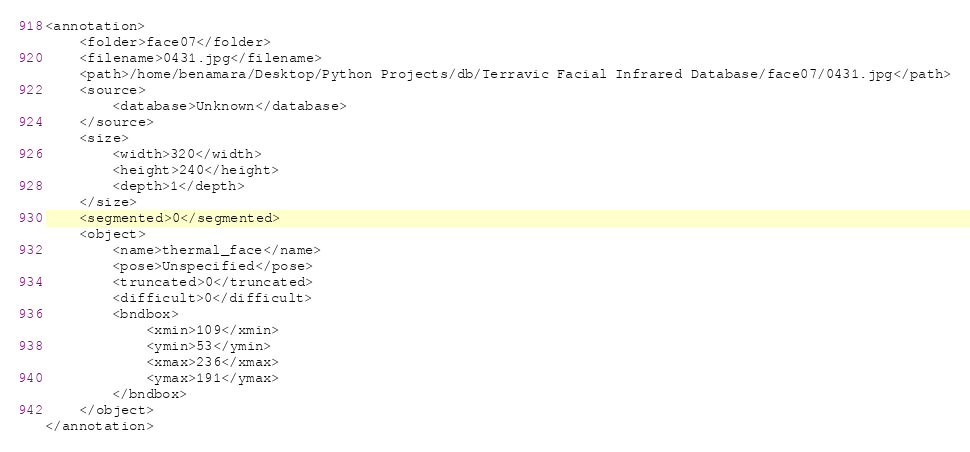Convert code to text. <code><loc_0><loc_0><loc_500><loc_500><_XML_><annotation>
	<folder>face07</folder>
	<filename>0431.jpg</filename>
	<path>/home/benamara/Desktop/Python Projects/db/Terravic Facial Infrared Database/face07/0431.jpg</path>
	<source>
		<database>Unknown</database>
	</source>
	<size>
		<width>320</width>
		<height>240</height>
		<depth>1</depth>
	</size>
	<segmented>0</segmented>
	<object>
		<name>thermal_face</name>
		<pose>Unspecified</pose>
		<truncated>0</truncated>
		<difficult>0</difficult>
		<bndbox>
			<xmin>109</xmin>
			<ymin>53</ymin>
			<xmax>236</xmax>
			<ymax>191</ymax>
		</bndbox>
	</object>
</annotation>
</code> 